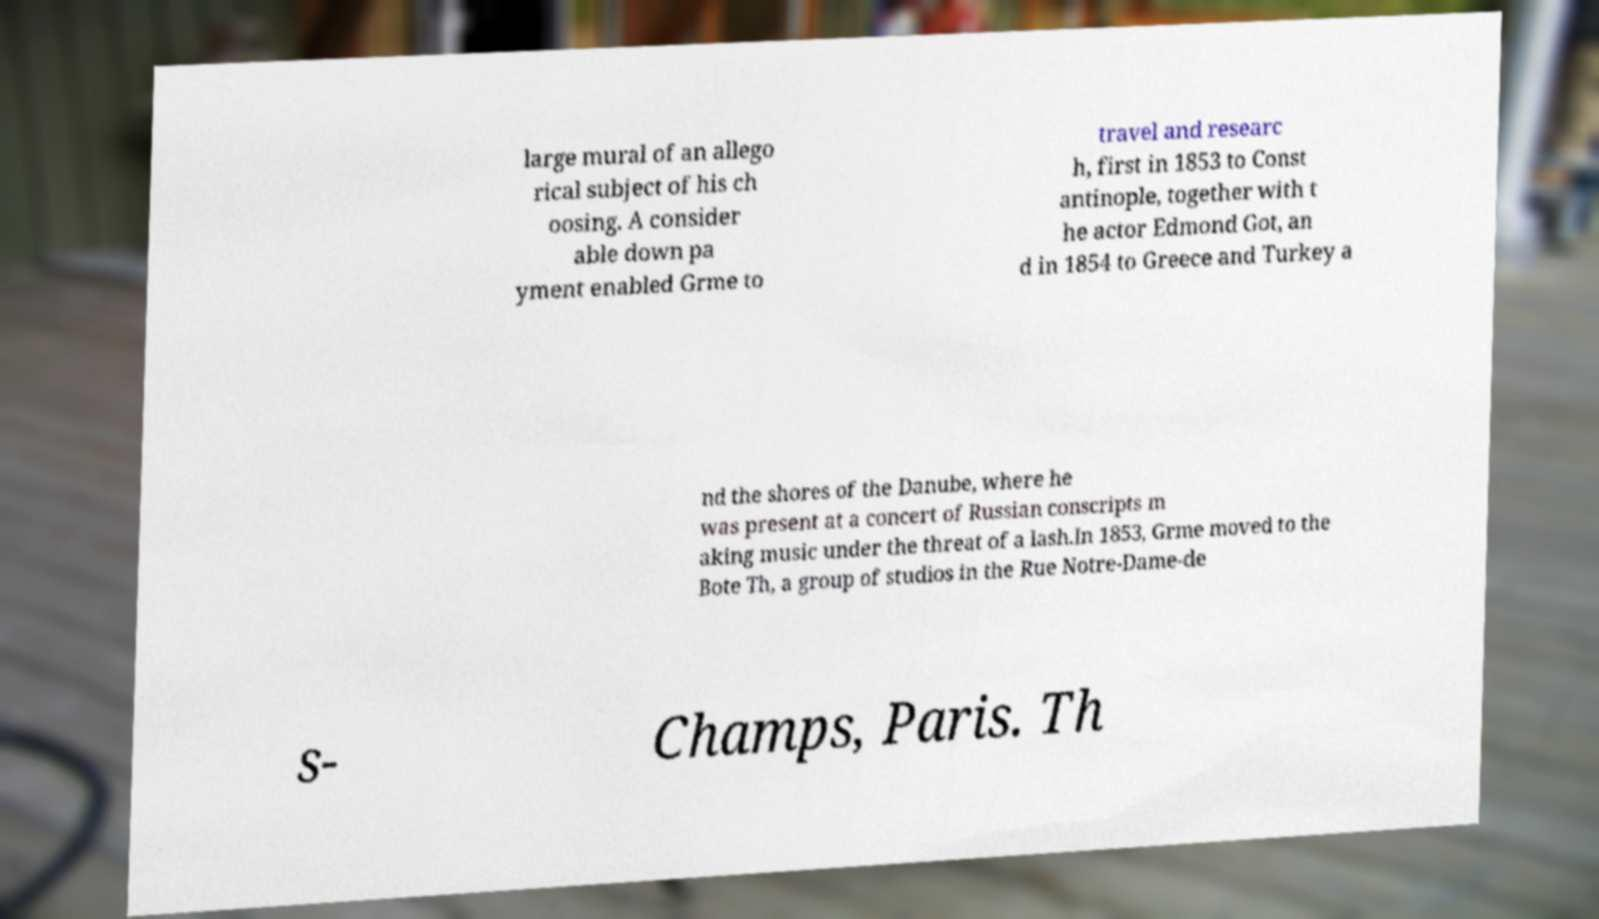For documentation purposes, I need the text within this image transcribed. Could you provide that? large mural of an allego rical subject of his ch oosing. A consider able down pa yment enabled Grme to travel and researc h, first in 1853 to Const antinople, together with t he actor Edmond Got, an d in 1854 to Greece and Turkey a nd the shores of the Danube, where he was present at a concert of Russian conscripts m aking music under the threat of a lash.In 1853, Grme moved to the Bote Th, a group of studios in the Rue Notre-Dame-de s- Champs, Paris. Th 